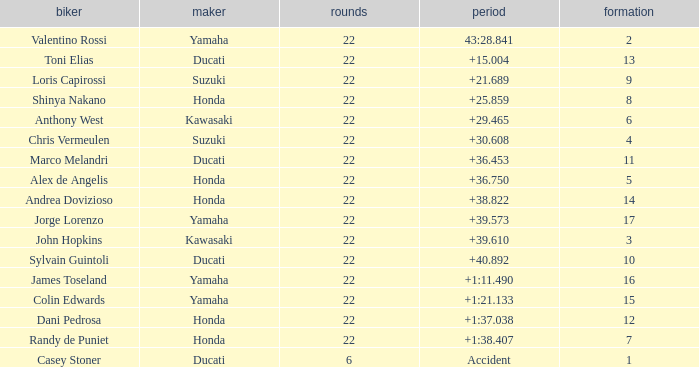Who had the lowest laps on a grid smaller than 16 with a time of +21.689? 22.0. 